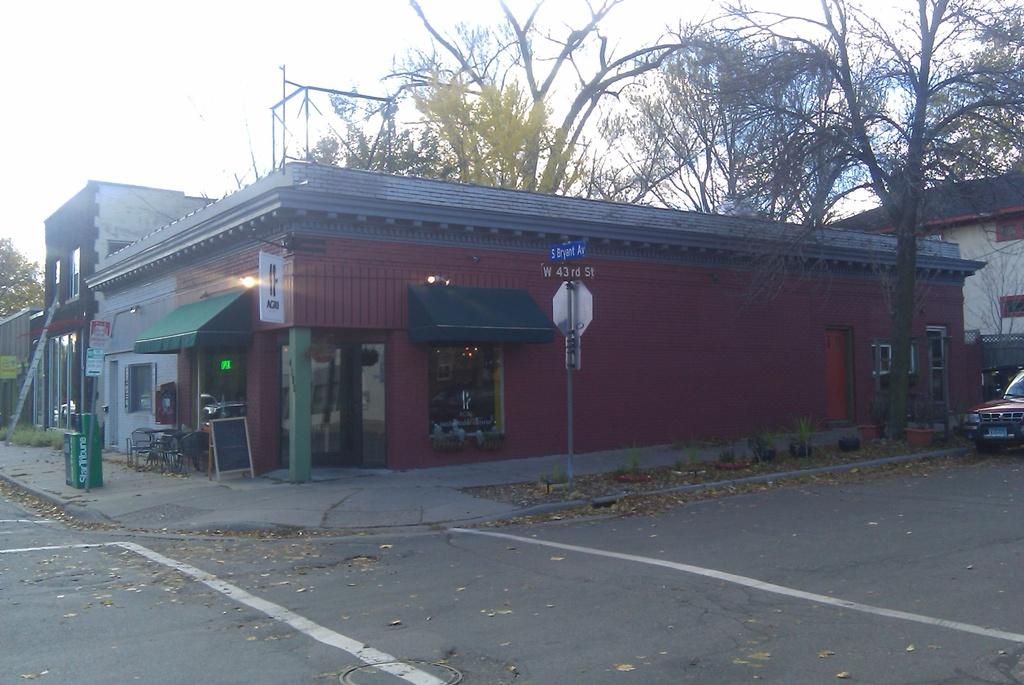What is the main feature of the image? There is a road in the image. What is on the road? There is a car on the road. What can be seen in the background of the image? There is a shop, poles, trees, and the sky visible in the background of the image. What type of creature is sitting on the car in the image? There is no creature sitting on the car in the image. Can you tell me how many brains are visible in the image? There are no brains visible in the image. 